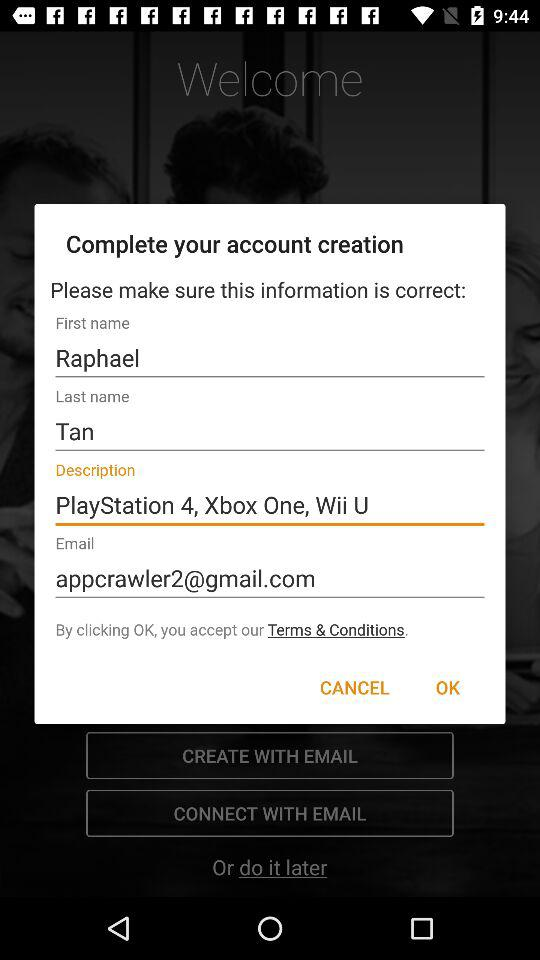What is the email address? The email address is appcrawler2@gmail.com. 